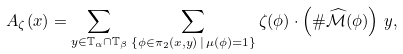<formula> <loc_0><loc_0><loc_500><loc_500>A _ { \zeta } ( { x } ) = \sum _ { { y } \in \mathbb { T } _ { \alpha } \cap \mathbb { T } _ { \beta } } \sum _ { \{ \phi \in \pi _ { 2 } ( { x } , { y } ) \, | \, \mu ( \phi ) = 1 \} } \zeta ( \phi ) \cdot \left ( \# \widehat { \mathcal { M } } ( \phi ) \right ) \, { y } ,</formula> 